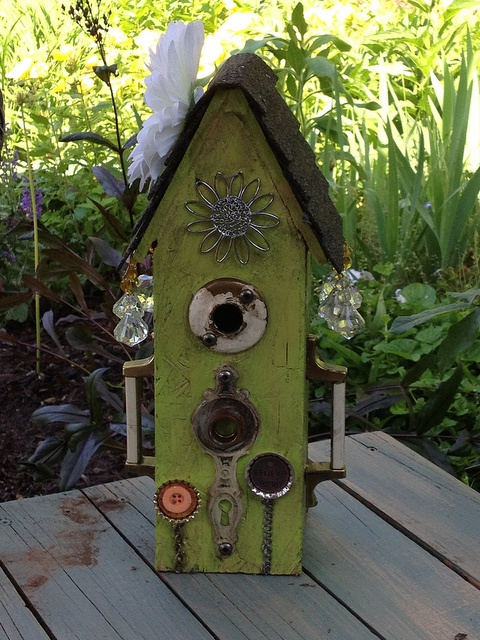Describe the objects in this image and their specific colors. I can see various objects in this image with different colors. 